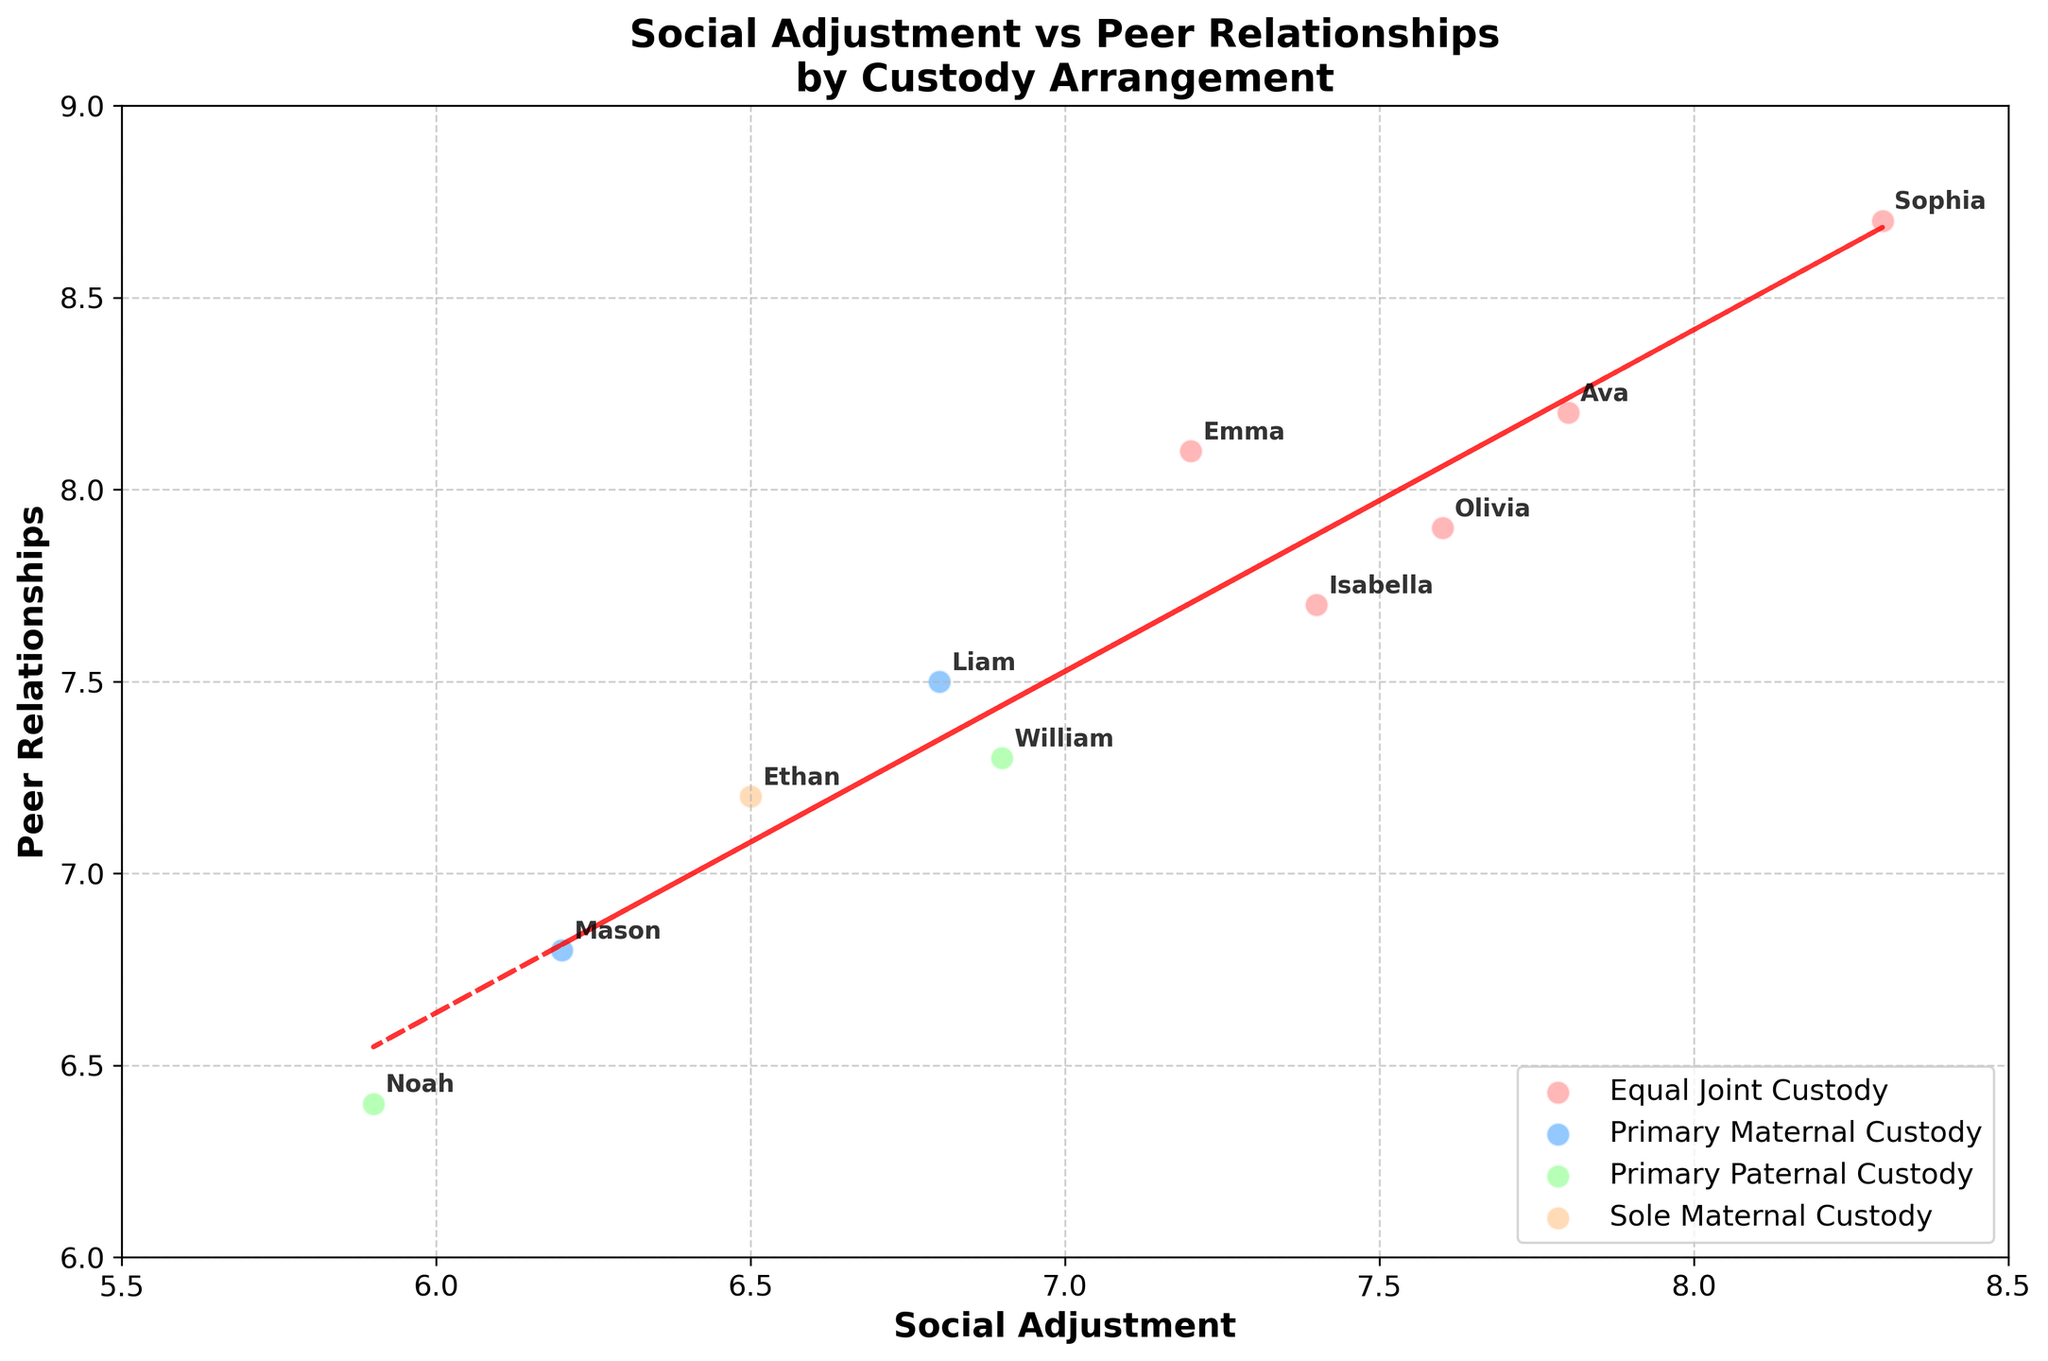What is the title of the plot? The title is provided at the top of the figure which reads 'Social Adjustment vs Peer Relationships\nby Custody Arrangement'
Answer: Social Adjustment vs Peer Relationships by Custody Arrangement What are the axis labels and their ranges? The x-axis label is 'Social Adjustment' with a range from 5.5 to 8.5, and the y-axis label is 'Peer Relationships' with a range from 6 to 9.
Answer: Social Adjustment (5.5 to 8.5), Peer Relationships (6 to 9) How many different custody arrangements are represented? There are four different custody arrangements as indicated by the legend: 'Equal Joint Custody,' 'Primary Maternal Custody,' 'Primary Paternal Custody,' and 'Sole Maternal Custody'.
Answer: Four Which custody arrangement appears to have children with the highest Social Adjustment and Peer Relationships scores? Viewing the different custody groups, 'Equal Joint Custody' has children like Sophia and Ava who have high scores in both categories, indicating this arrangement tends to have the highest scores.
Answer: Equal Joint Custody Which custody arrangement shows the lowest average Social Adjustment? By comparing the data points on the x-axis representing Social Adjustment, 'Primary Paternal Custody' has lower scores on average with Noah (5.9) and William (6.9).
Answer: Primary Paternal Custody Who has the highest Peer Relationships score and what is their custody arrangement? Sophia, with a Peer Relationships score of 8.7, has the highest score; her custody arrangement is 'Equal Joint Custody'.
Answer: Sophia, Equal Joint Custody What is the general trend between Social Adjustment and Peer Relationships scores based on the trend line? The trend line is upward sloping, indicating a positive relationship between Social Adjustment and Peer Relationships scores; as one increases, the other tends to increase as well.
Answer: Positive correlation How many children are under 'Primary Maternal Custody' and what are their Social Adjustment scores? There are two children under 'Primary Maternal Custody': Liam with a score of 6.8 and Mason with a score of 6.2.
Answer: Two children, 6.8 and 6.2 Which child under 'Sole Maternal Custody' has what Peer Relationships score? Ethan is the only child under 'Sole Maternal Custody' with a Peer Relationships score of 7.2.
Answer: Ethan, 7.2 Who are the children with equal joint custody? The children with 'Equal Joint Custody' are Emma, Sophia, Olivia, Ava, and Isabella, as indicated by the figure's legend and plotted points.
Answer: Emma, Sophia, Olivia, Ava, Isabella 